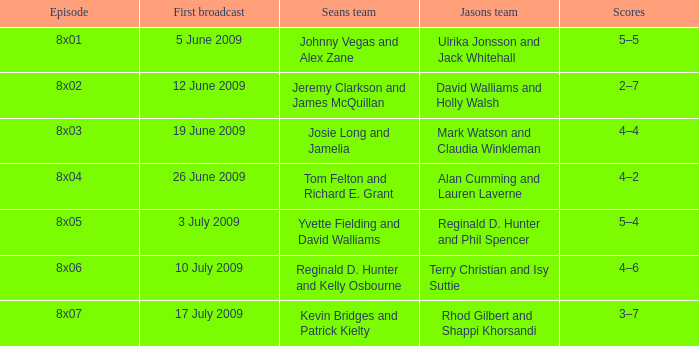In what number of episodes were jeremy clarkson and james mcquillan a part of sean's team? 1.0. 